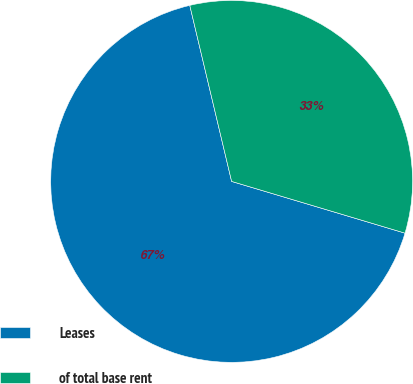Convert chart to OTSL. <chart><loc_0><loc_0><loc_500><loc_500><pie_chart><fcel>Leases<fcel>of total base rent<nl><fcel>66.67%<fcel>33.33%<nl></chart> 